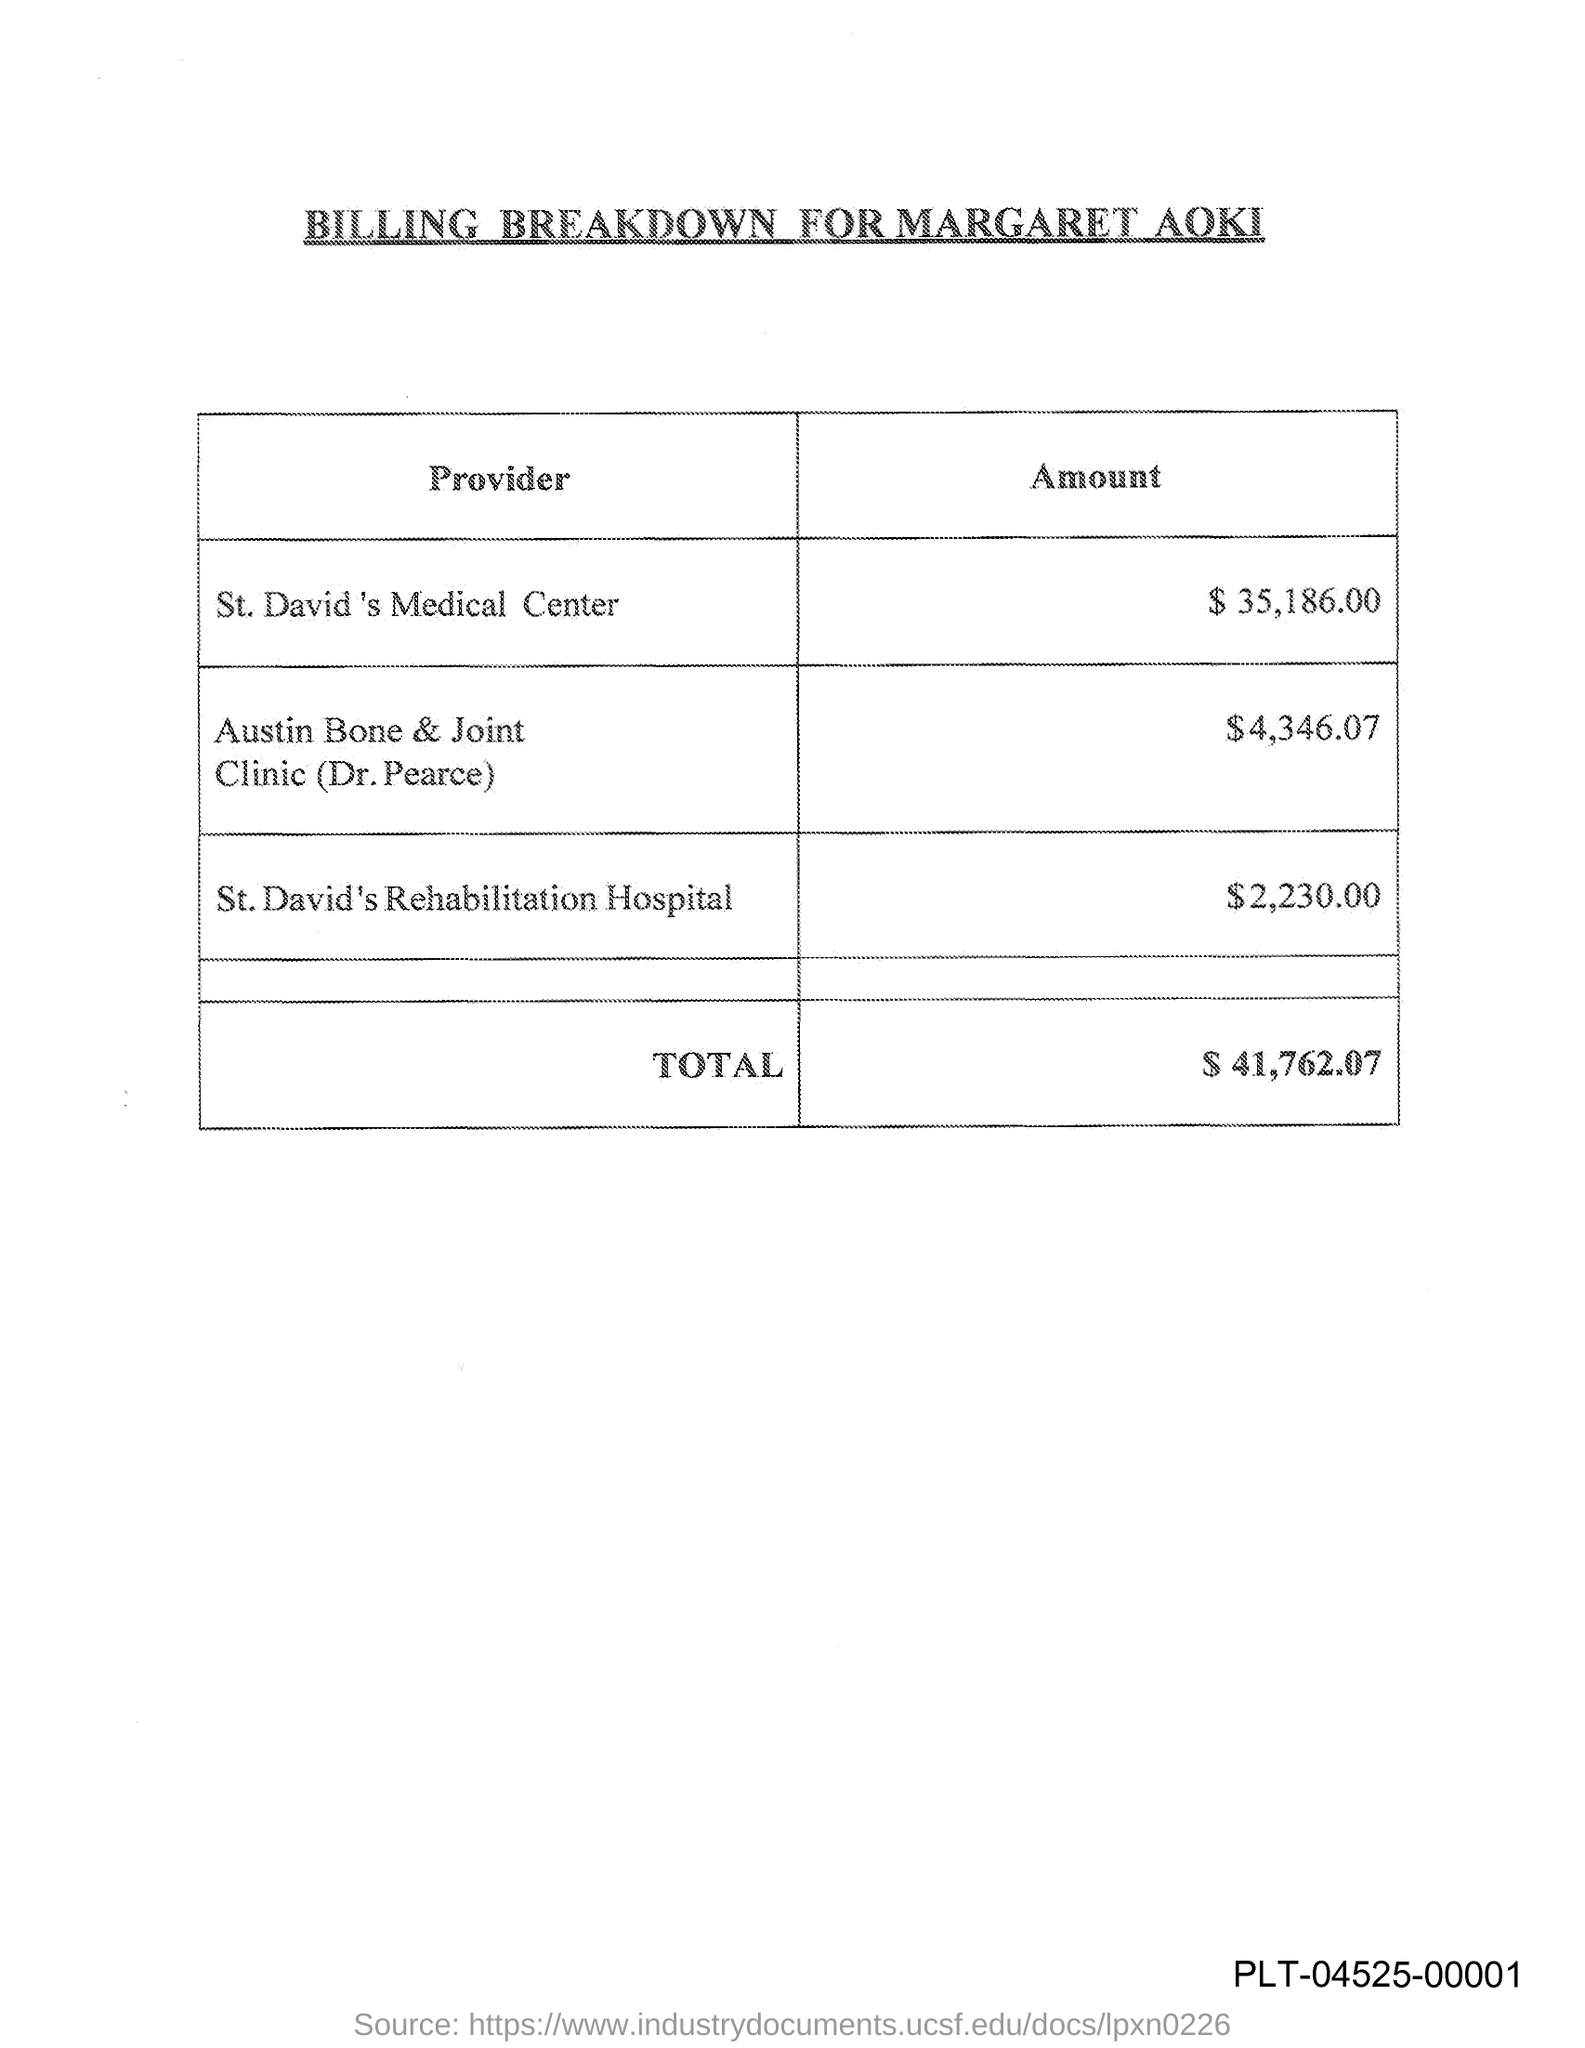What is the title of this document?
Your response must be concise. BILLING BREAKDOWN FOR MARGARET AOKI. What is the amount mentioned for St. David's Medical Center?
Your answer should be very brief. $ 35,186.00. What is the amount mentioned for St. David's Rehabilitation Hospital?
Offer a terse response. $2,230.00. What is the total amount given in the document?
Provide a succinct answer. $41,762.07. 